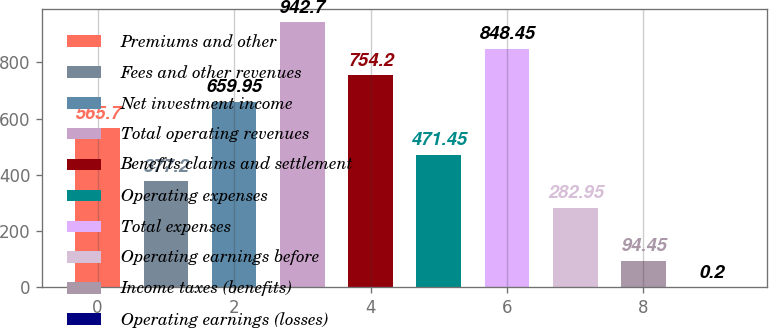<chart> <loc_0><loc_0><loc_500><loc_500><bar_chart><fcel>Premiums and other<fcel>Fees and other revenues<fcel>Net investment income<fcel>Total operating revenues<fcel>Benefits claims and settlement<fcel>Operating expenses<fcel>Total expenses<fcel>Operating earnings before<fcel>Income taxes (benefits)<fcel>Operating earnings (losses)<nl><fcel>565.7<fcel>377.2<fcel>659.95<fcel>942.7<fcel>754.2<fcel>471.45<fcel>848.45<fcel>282.95<fcel>94.45<fcel>0.2<nl></chart> 